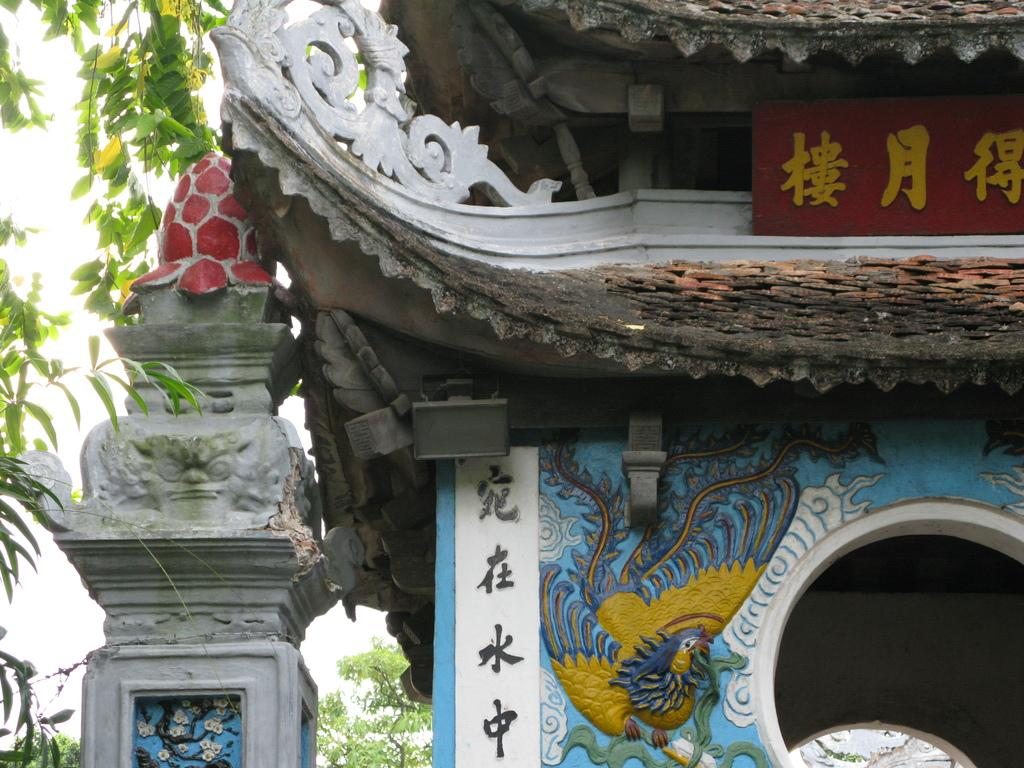What is the main subject in the foreground of the image? There is a monument in the foreground of the image. What can be seen in the background of the image? There are trees and the sky visible in the background of the image. Where is the stem of the flower located in the image? There is no flower or stem present in the image; it features a monument and trees in the background. 